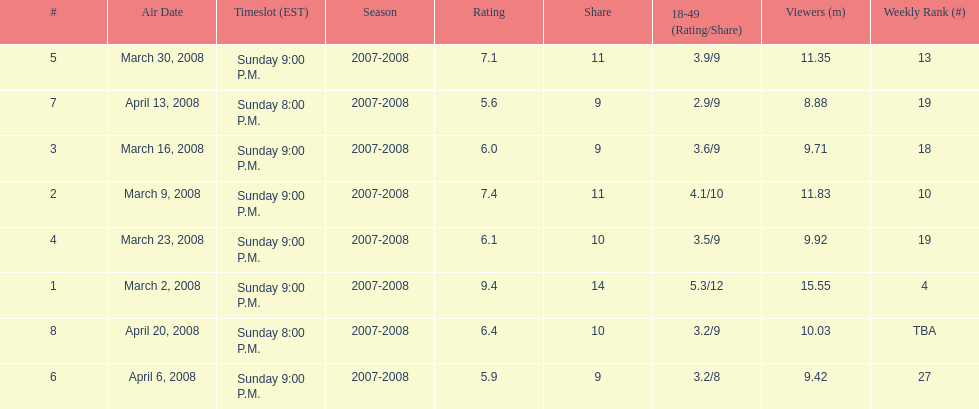Which show had the highest rating? 1. 